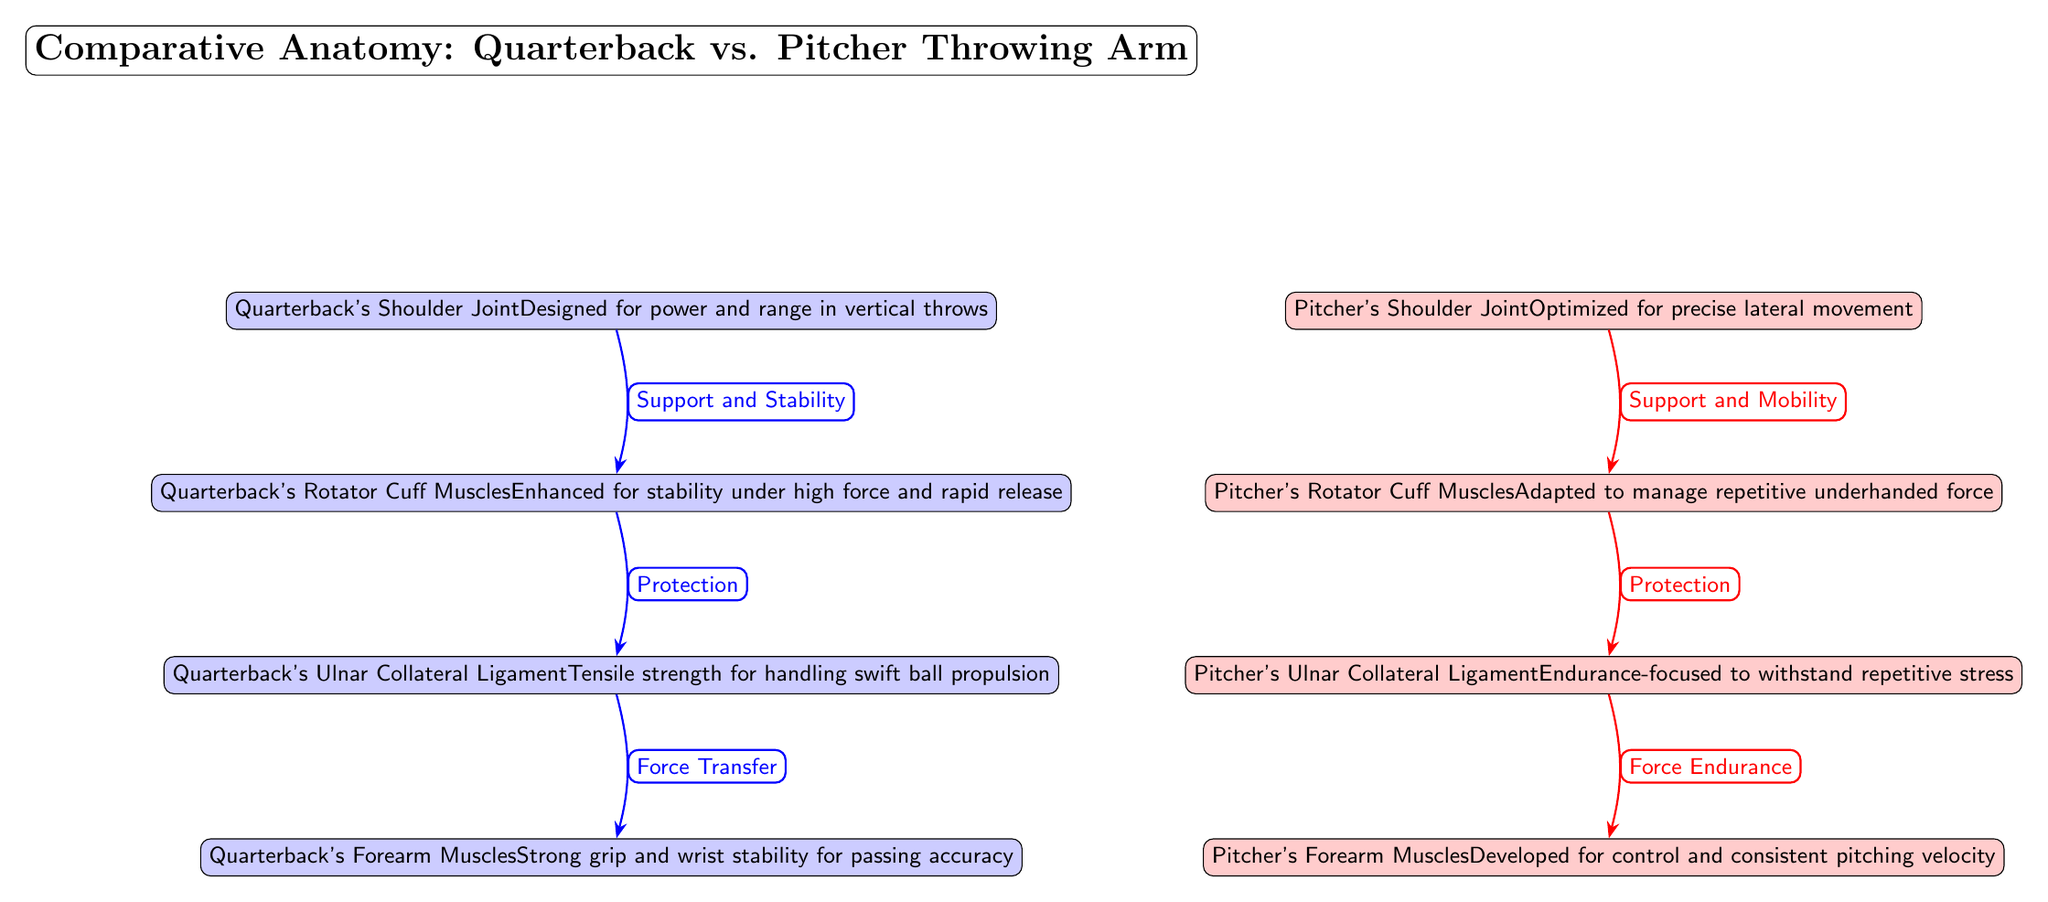What does the Quarterback's Shoulder Joint optimize for? In the diagram, the Quarterback's Shoulder Joint is labeled as "Designed for power and range in vertical throws," which indicates its primary role in facilitating powerful and long-range throws typical for a quarterback.
Answer: power and range in vertical throws What role do the Quarterback's Rotator Cuff Muscles serve? The Quarterback's Rotator Cuff Muscles are defined as "Enhanced for stability under high force and rapid release," suggesting that they are crucial for maintaining shoulder stability during vigorous throwing movements.
Answer: stability under high force and rapid release How many joints are mentioned in the diagram? The diagram indicates two shoulder joints, one for the quarterback and one for the pitcher, which can be counted directly from the nodes depicted.
Answer: 2 Which ligament has a focus on endurance in the diagram? The Pitcher's Ulnar Collateral Ligament is described as "Endurance-focused to withstand repetitive stress," highlighting its adaptability for sustained performance in repetitive throwing motions.
Answer: Endurance-focused What is the relationship type indicated between the Quarterback's Shoulder Joint and the Quarterback's Rotator Cuff Muscles? The diagram shows an edge labeled "Support and Stability" connecting the Quarterback's Shoulder Joint to the Quarterback's Rotator Cuff Muscles, indicating a supportive relationship that enhances stability.
Answer: Support and Stability Which arm's forearm muscles are developed for control? The diagram specifies that the Pitcher's Forearm Muscles are "Developed for control and consistent pitching velocity," indicating that these muscles are tailored for precision in their arm movements.
Answer: Pitcher's Forearm Muscles What do the Quarterback's Forearm Muscles focus on enhancing? The Quarterback's Forearm Muscles are characterized in the diagram as having a "Strong grip and wrist stability for passing accuracy," indicating their role in maintaining accuracy during throws.
Answer: Strong grip and wrist stability for passing accuracy What type of movement is the Pitcher's Shoulder Joint optimized for? According to the diagram, the Pitcher's Shoulder Joint is "Optimized for precise lateral movement," indicating its adaptation for the lateral motion involved in pitching.
Answer: precise lateral movement 